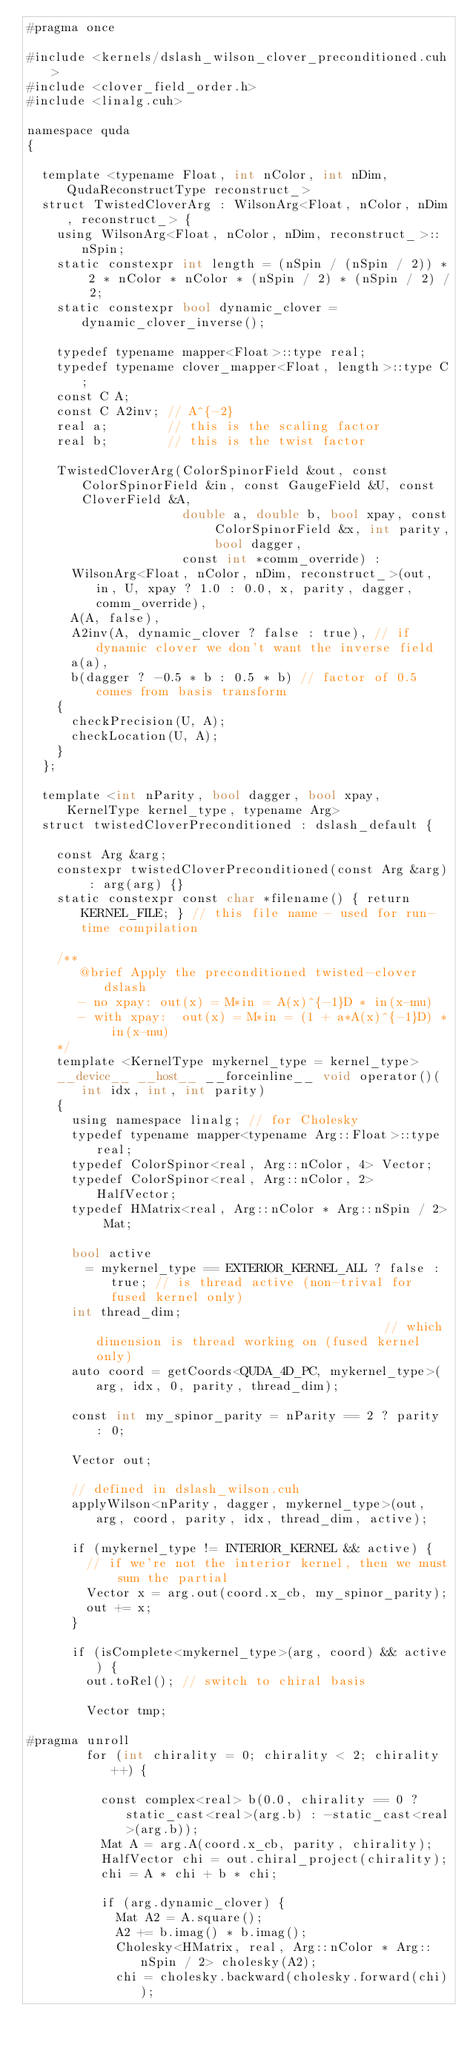<code> <loc_0><loc_0><loc_500><loc_500><_Cuda_>#pragma once

#include <kernels/dslash_wilson_clover_preconditioned.cuh>
#include <clover_field_order.h>
#include <linalg.cuh>

namespace quda
{

  template <typename Float, int nColor, int nDim, QudaReconstructType reconstruct_>
  struct TwistedCloverArg : WilsonArg<Float, nColor, nDim, reconstruct_> {
    using WilsonArg<Float, nColor, nDim, reconstruct_>::nSpin;
    static constexpr int length = (nSpin / (nSpin / 2)) * 2 * nColor * nColor * (nSpin / 2) * (nSpin / 2) / 2;
    static constexpr bool dynamic_clover = dynamic_clover_inverse();

    typedef typename mapper<Float>::type real;
    typedef typename clover_mapper<Float, length>::type C;
    const C A;
    const C A2inv; // A^{-2}
    real a;        // this is the scaling factor
    real b;        // this is the twist factor

    TwistedCloverArg(ColorSpinorField &out, const ColorSpinorField &in, const GaugeField &U, const CloverField &A,
                     double a, double b, bool xpay, const ColorSpinorField &x, int parity, bool dagger,
                     const int *comm_override) :
      WilsonArg<Float, nColor, nDim, reconstruct_>(out, in, U, xpay ? 1.0 : 0.0, x, parity, dagger, comm_override),
      A(A, false),
      A2inv(A, dynamic_clover ? false : true), // if dynamic clover we don't want the inverse field
      a(a),
      b(dagger ? -0.5 * b : 0.5 * b) // factor of 0.5 comes from basis transform
    {
      checkPrecision(U, A);
      checkLocation(U, A);
    }
  };

  template <int nParity, bool dagger, bool xpay, KernelType kernel_type, typename Arg>
  struct twistedCloverPreconditioned : dslash_default {

    const Arg &arg;
    constexpr twistedCloverPreconditioned(const Arg &arg) : arg(arg) {}
    static constexpr const char *filename() { return KERNEL_FILE; } // this file name - used for run-time compilation

    /**
       @brief Apply the preconditioned twisted-clover dslash
       - no xpay: out(x) = M*in = A(x)^{-1}D * in(x-mu)
       - with xpay:  out(x) = M*in = (1 + a*A(x)^{-1}D) * in(x-mu)
    */
    template <KernelType mykernel_type = kernel_type>
    __device__ __host__ __forceinline__ void operator()(int idx, int, int parity)
    {
      using namespace linalg; // for Cholesky
      typedef typename mapper<typename Arg::Float>::type real;
      typedef ColorSpinor<real, Arg::nColor, 4> Vector;
      typedef ColorSpinor<real, Arg::nColor, 2> HalfVector;
      typedef HMatrix<real, Arg::nColor * Arg::nSpin / 2> Mat;

      bool active
        = mykernel_type == EXTERIOR_KERNEL_ALL ? false : true; // is thread active (non-trival for fused kernel only)
      int thread_dim;                                        // which dimension is thread working on (fused kernel only)
      auto coord = getCoords<QUDA_4D_PC, mykernel_type>(arg, idx, 0, parity, thread_dim);

      const int my_spinor_parity = nParity == 2 ? parity : 0;

      Vector out;

      // defined in dslash_wilson.cuh
      applyWilson<nParity, dagger, mykernel_type>(out, arg, coord, parity, idx, thread_dim, active);

      if (mykernel_type != INTERIOR_KERNEL && active) {
        // if we're not the interior kernel, then we must sum the partial
        Vector x = arg.out(coord.x_cb, my_spinor_parity);
        out += x;
      }

      if (isComplete<mykernel_type>(arg, coord) && active) {
        out.toRel(); // switch to chiral basis

        Vector tmp;

#pragma unroll
        for (int chirality = 0; chirality < 2; chirality++) {

          const complex<real> b(0.0, chirality == 0 ? static_cast<real>(arg.b) : -static_cast<real>(arg.b));
          Mat A = arg.A(coord.x_cb, parity, chirality);
          HalfVector chi = out.chiral_project(chirality);
          chi = A * chi + b * chi;

          if (arg.dynamic_clover) {
            Mat A2 = A.square();
            A2 += b.imag() * b.imag();
            Cholesky<HMatrix, real, Arg::nColor * Arg::nSpin / 2> cholesky(A2);
            chi = cholesky.backward(cholesky.forward(chi));</code> 